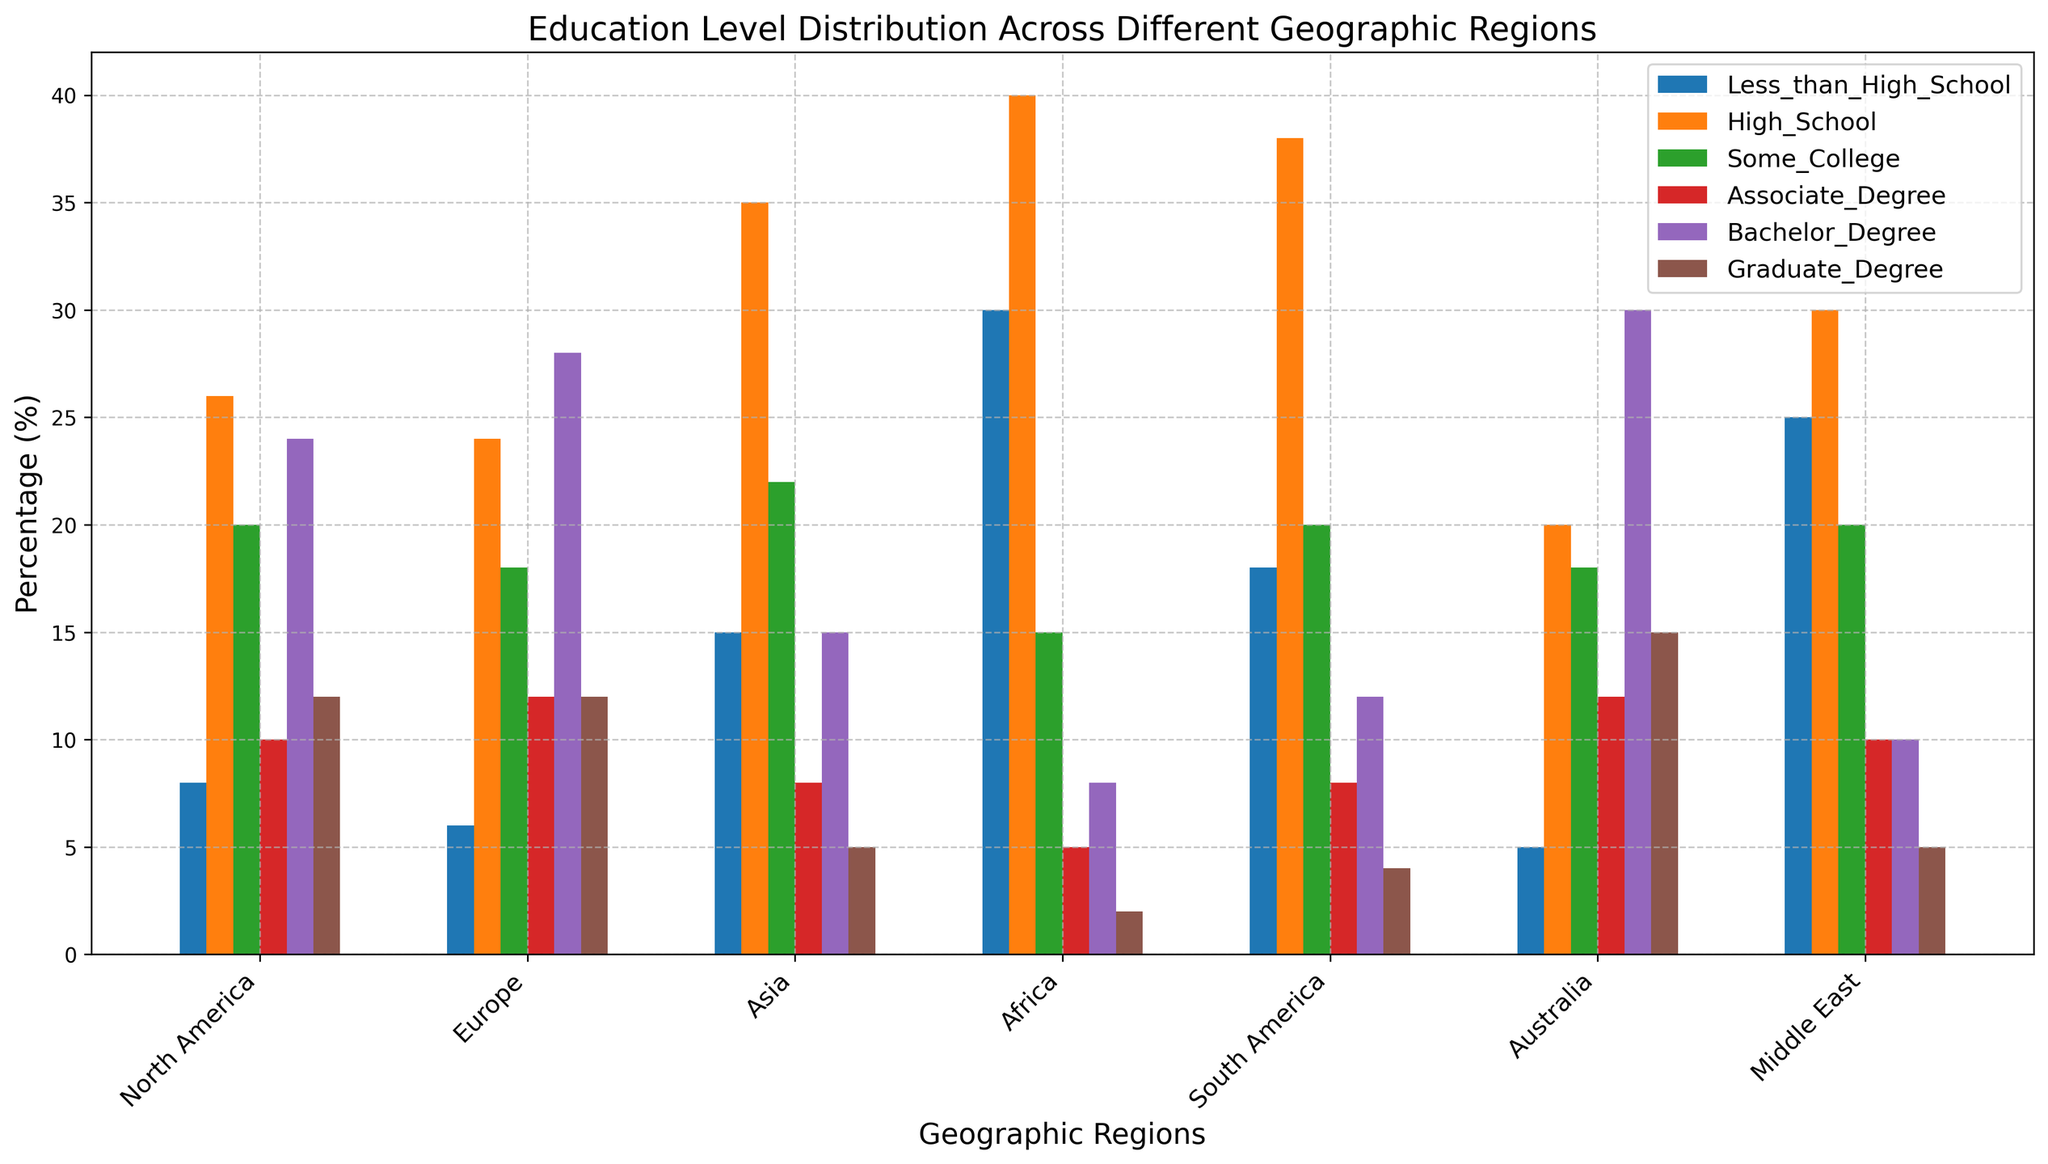Which region has the highest percentage of individuals with a Bachelor Degree? First, look at the bars representing "Bachelor Degree" for each region. The tallest bar corresponds to Australia.
Answer: Australia Which regions have a lower percentage of individuals with a High School education compared to the Global average, calculated across all regions? Calculate the average percentage for High School across all regions: (26+24+35+40+38+20+30) / 7 = 303/7 ≈ 43. Unsurprisingly, the regions with values below this average are North America, Europe, Australia, and Middle East.
Answer: North America, Europe, Australia, Middle East Which two regions combined have a similar percentage of Graduate Degree holders as Asia? Asia has 5% with Graduate Degrees. Combining Africa (2%) and Middle East (5%), they total 7%, closely aligning to the percentage in Asia.
Answer: Africa and Middle East Between North America and Europe, which region has a higher percentage of Associate Degree holders? Compare the "Associate Degree" bars for North America (10%) and Europe (12%) and find that Europe has a higher percentage.
Answer: Europe Which region has the highest percentage of people with less than a high school education? Identify the tallest bar in the "Less_than_High_School" category, which is for Africa at 30%.
Answer: Africa What is the total percentage of individuals with some college education in the Middle East and North America combined? North America has 20% and Middle East has 20% for "Some_College", resulting in a combined total of 20 + 20 = 40%.
Answer: 40% Which region has the widest range between the highest and lowest percentages for any education level? Measure the range by comparing the highest and lowest categories: For Africa, it ranges from 40% (High School) down to 2% (Graduate Degree), giving a range of 40 - 2 = 38%. No other region has a wider range.
Answer: Africa What is the average percentage of Graduate Degree holders across all regions? Calculate this using the values (12+12+5+2+4+15+5)/7 = 55/7 ≈ 7.86 %.
Answer: 7.86% Which region has more individuals with an Associate Degree than with less than a high school education? Compare the values for "Associate_Degree" and "Less_than_High_School": Australia (12% vs. 5%) meets this condition.
Answer: Australia 